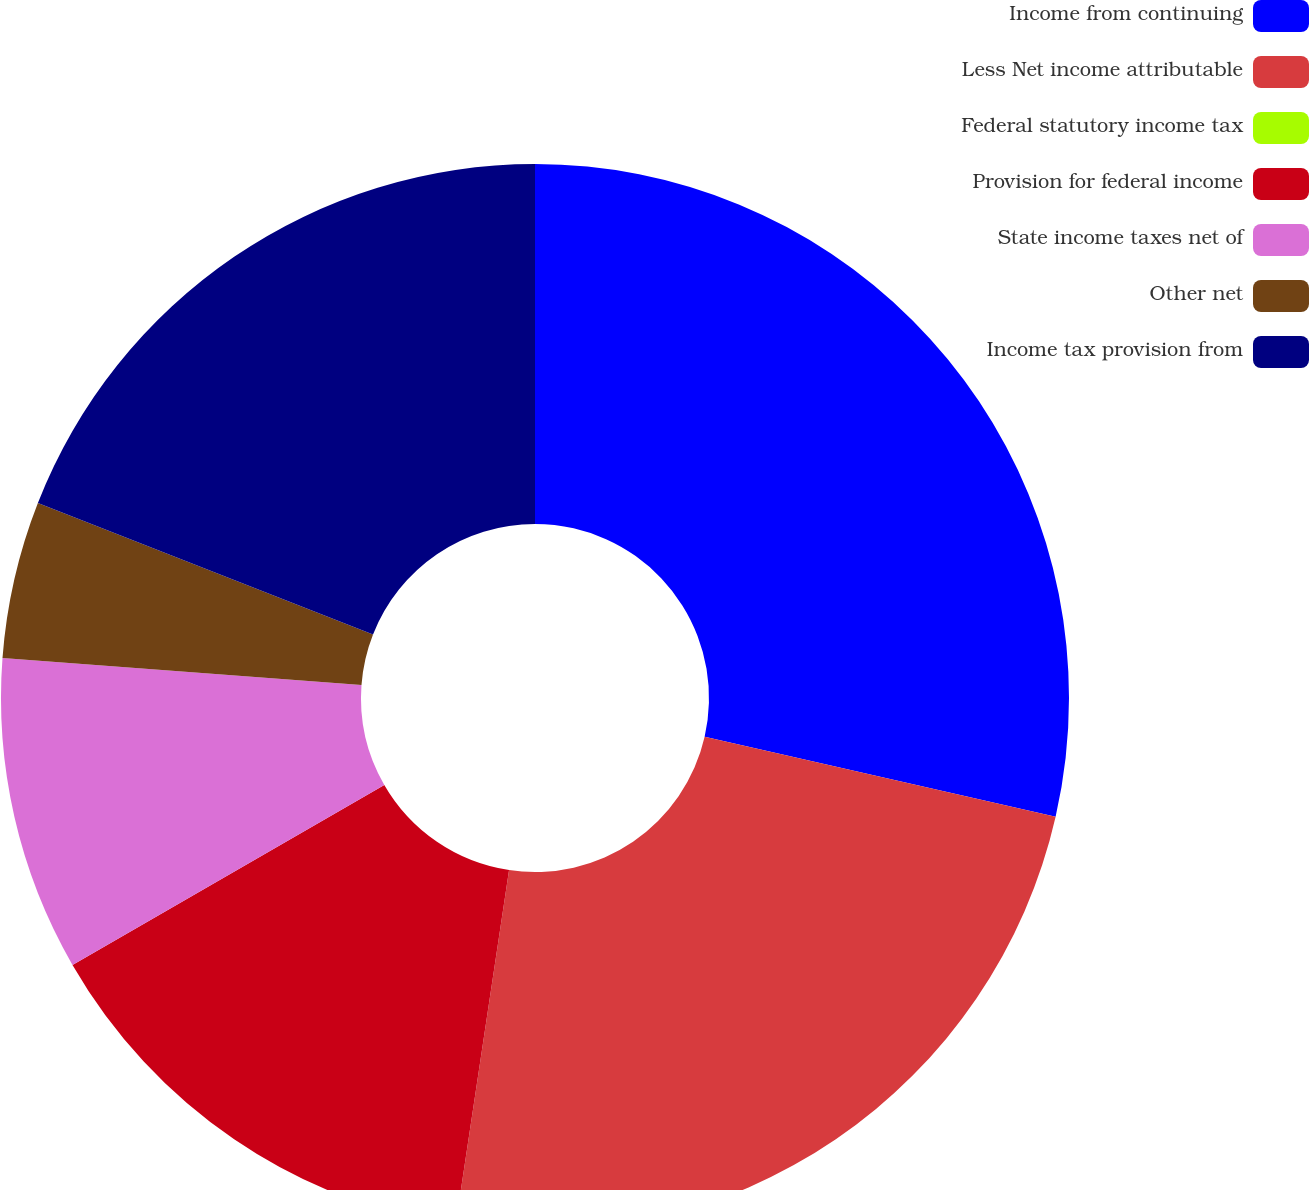<chart> <loc_0><loc_0><loc_500><loc_500><pie_chart><fcel>Income from continuing<fcel>Less Net income attributable<fcel>Federal statutory income tax<fcel>Provision for federal income<fcel>State income taxes net of<fcel>Other net<fcel>Income tax provision from<nl><fcel>28.57%<fcel>23.81%<fcel>0.0%<fcel>14.29%<fcel>9.52%<fcel>4.76%<fcel>19.05%<nl></chart> 